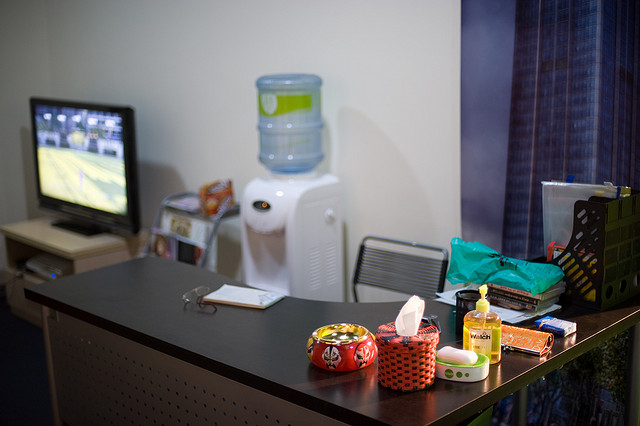<image>What item in the picture can be worn? I am not sure what item in the picture can be worn. It can be glasses or a shirt. What item in the picture can be worn? It is ambiguous what item in the picture can be worn. It can be seen glasses or shirt. 